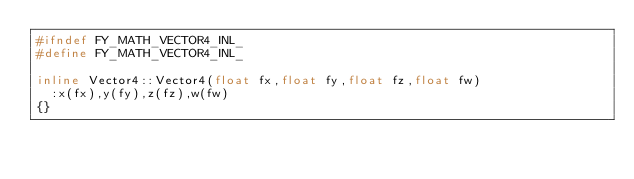Convert code to text. <code><loc_0><loc_0><loc_500><loc_500><_C++_>#ifndef FY_MATH_VECTOR4_INL_
#define FY_MATH_VECTOR4_INL_

inline Vector4::Vector4(float fx,float fy,float fz,float fw)
	:x(fx),y(fy),z(fz),w(fw)
{}
</code> 